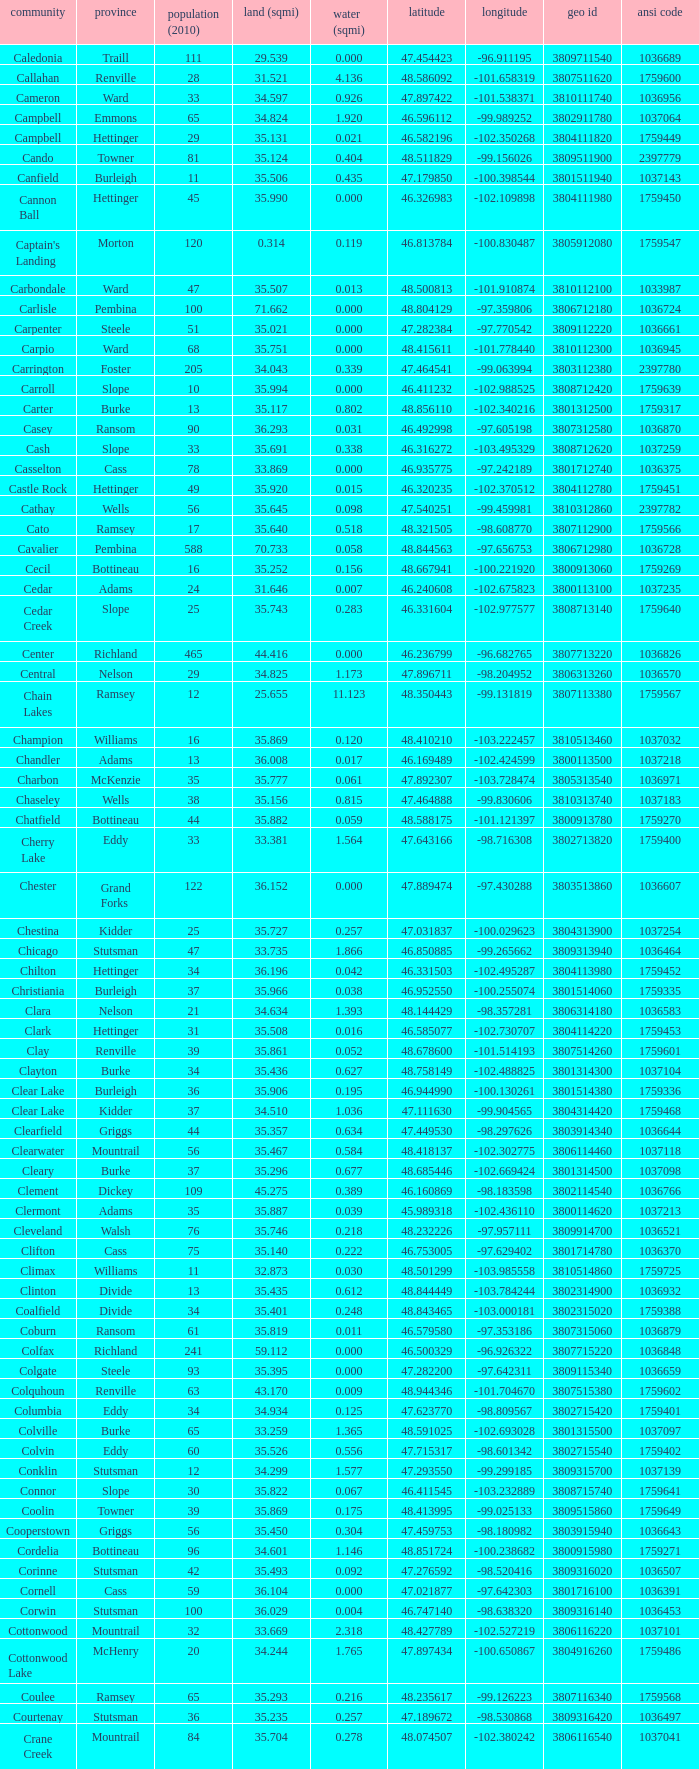What is the land area in square miles at a latitude of 48.763937? 35.898. 